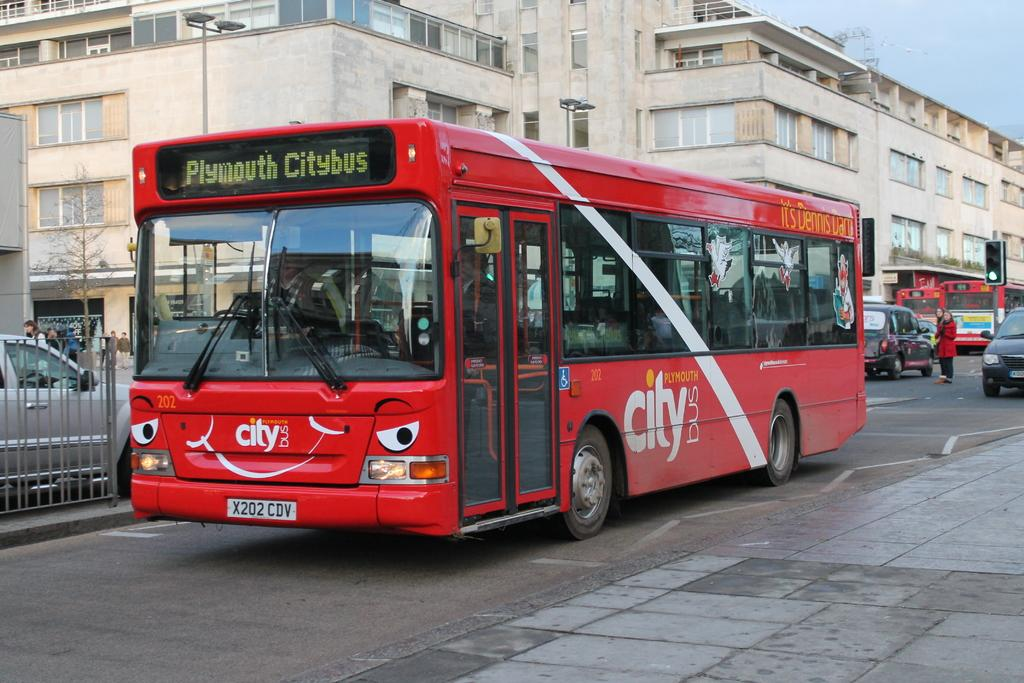<image>
Describe the image concisely. A medium sized red bus owned by Citybus in Plymouth. 